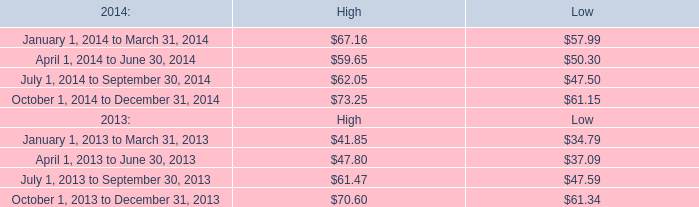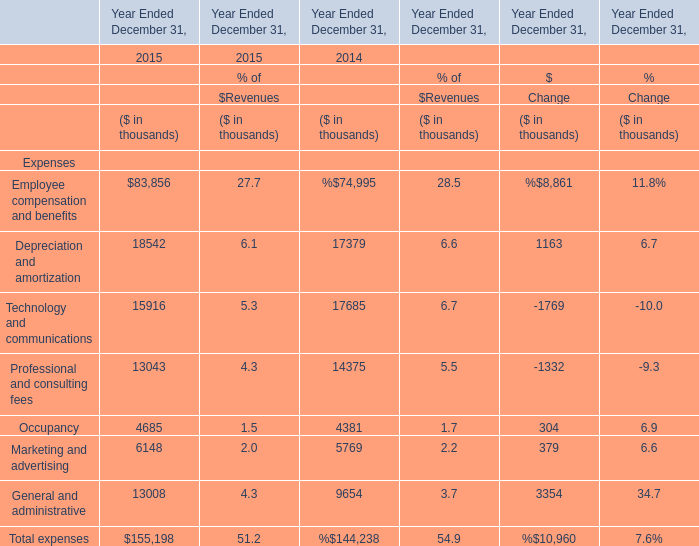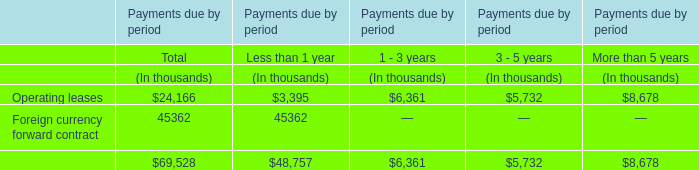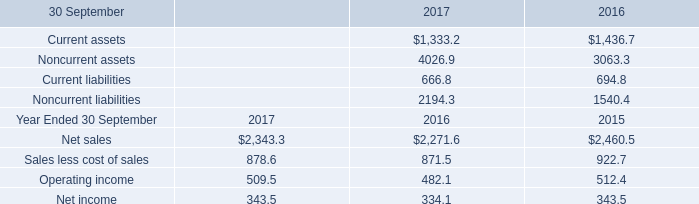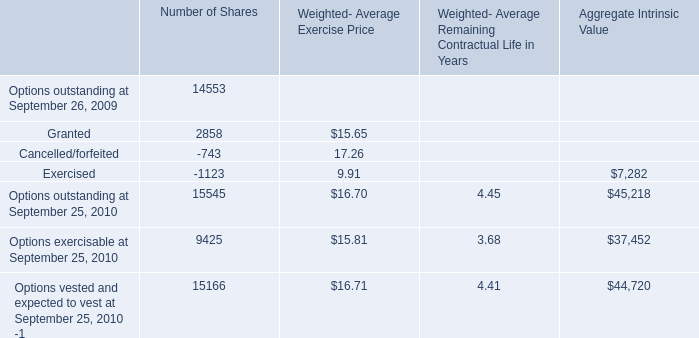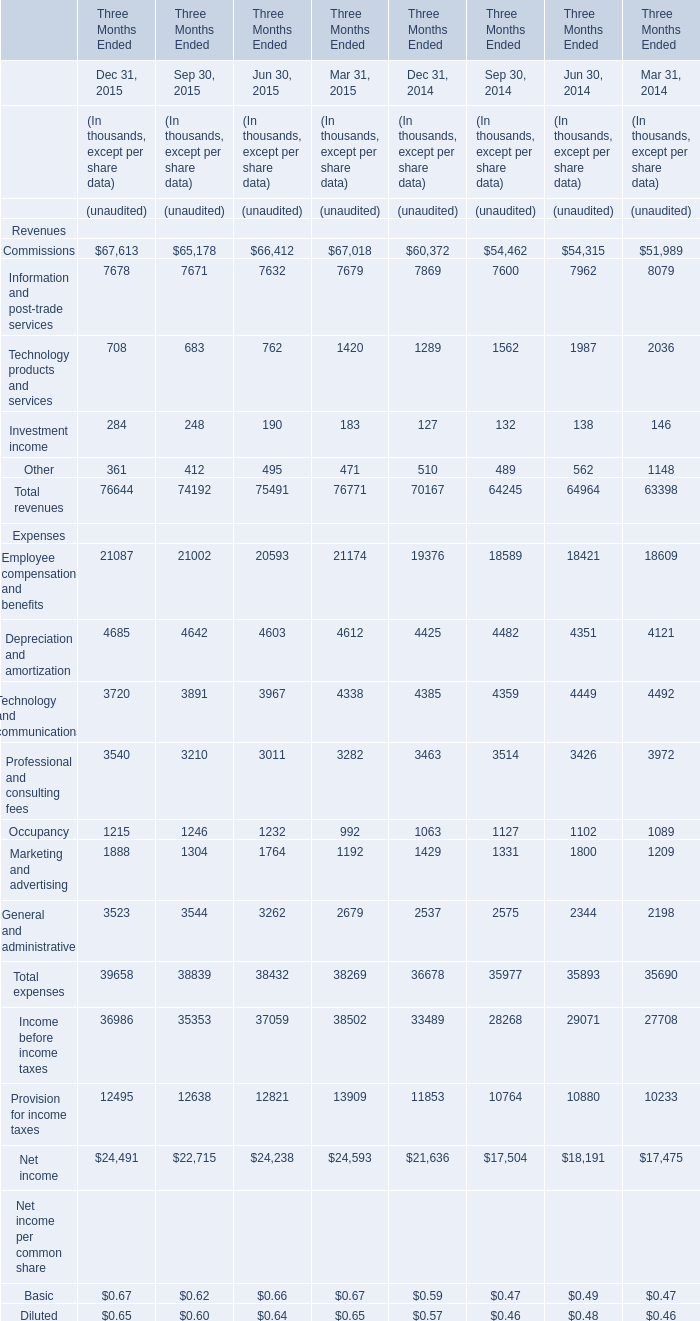What will Depreciation and amortization be like in 2015 if it develops with the same increasing rate as current? (in thousand) 
Computations: (18542 * (1 + ((18542 - 17379) / 18542)))
Answer: 19705.0. 